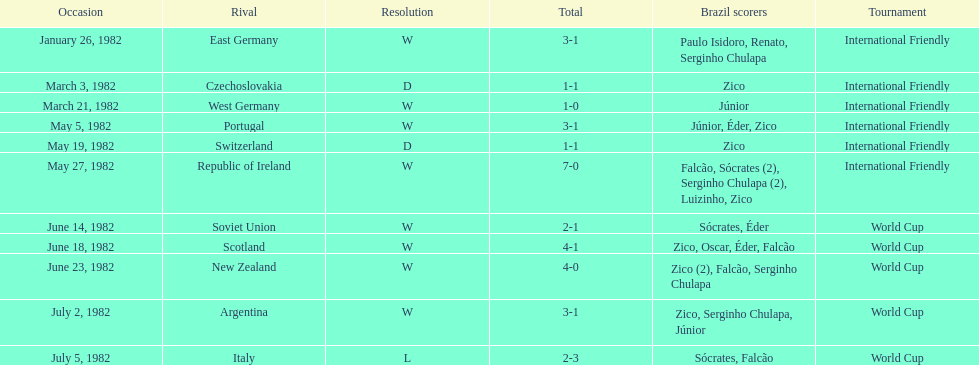What was the total number of games this team played in 1982? 11. 